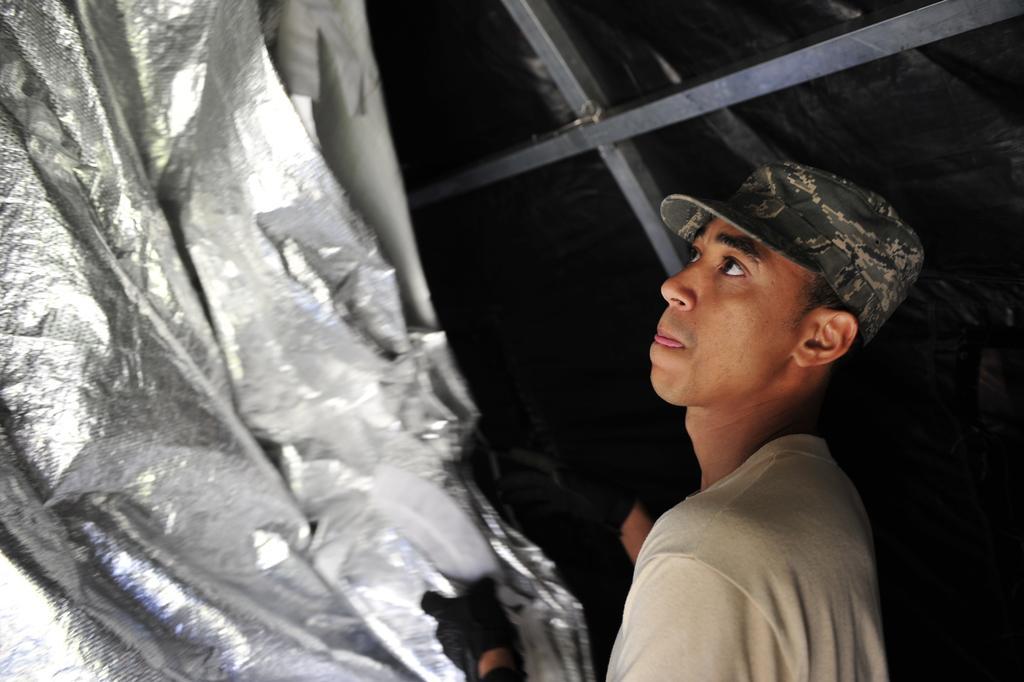Please provide a concise description of this image. In this image we can see few people. There are few metallic rods in the image. There is an object at the left side of the image. A person is wearing a cap in the image. 